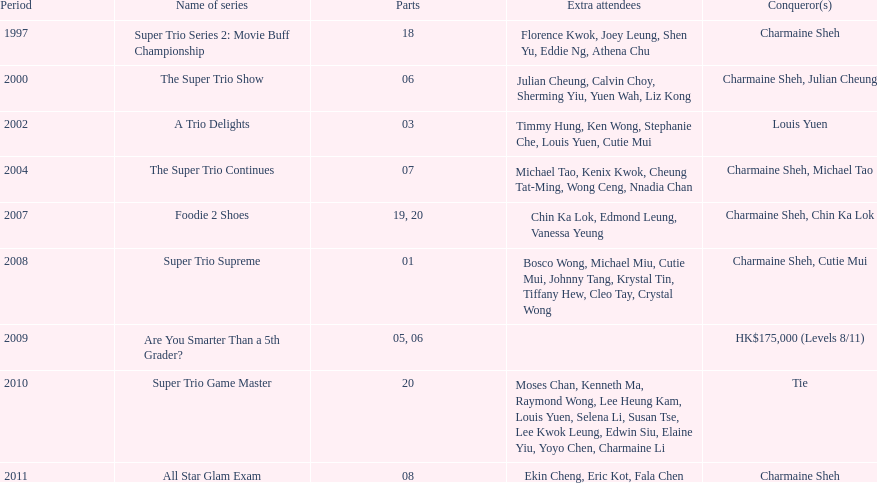What is the number of tv shows that charmaine sheh has appeared on? 9. 